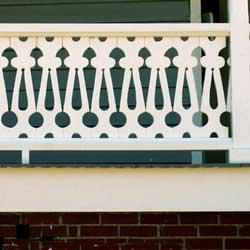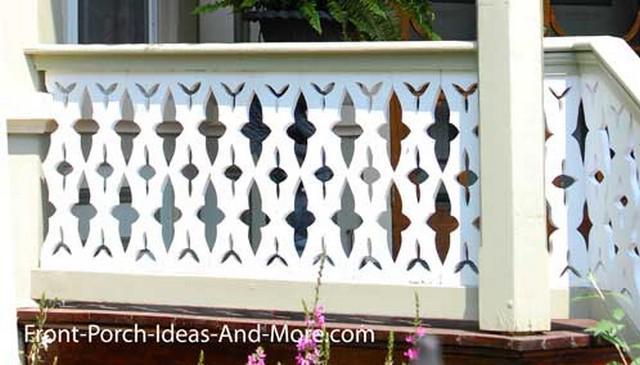The first image is the image on the left, the second image is the image on the right. Examine the images to the left and right. Is the description "there is a decorative porch rail on the front porch, with the outside of the home visible and windows" accurate? Answer yes or no. No. The first image is the image on the left, the second image is the image on the right. Assess this claim about the two images: "The left image shows a white-painted rail with decorative geometric cut-outs instead of spindles, above red brick.". Correct or not? Answer yes or no. Yes. 